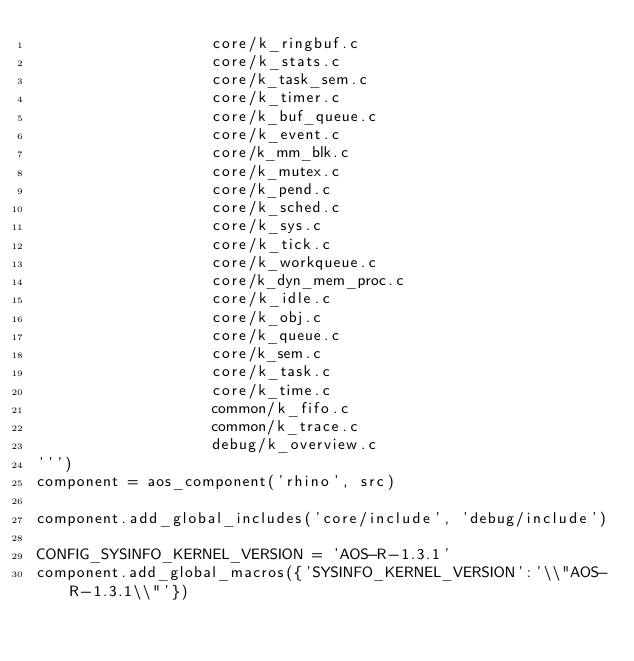<code> <loc_0><loc_0><loc_500><loc_500><_Python_>                   core/k_ringbuf.c      
                   core/k_stats.c        
                   core/k_task_sem.c     
                   core/k_timer.c        
                   core/k_buf_queue.c    
                   core/k_event.c        
                   core/k_mm_blk.c       
                   core/k_mutex.c        
                   core/k_pend.c         
                   core/k_sched.c        
                   core/k_sys.c          
                   core/k_tick.c         
                   core/k_workqueue.c    
                   core/k_dyn_mem_proc.c 
                   core/k_idle.c         
                   core/k_obj.c          
                   core/k_queue.c        
                   core/k_sem.c          
                   core/k_task.c         
                   core/k_time.c         
                   common/k_fifo.c       
                   common/k_trace.c
                   debug/k_overview.c
''')
component = aos_component('rhino', src)

component.add_global_includes('core/include', 'debug/include')

CONFIG_SYSINFO_KERNEL_VERSION = 'AOS-R-1.3.1'
component.add_global_macros({'SYSINFO_KERNEL_VERSION':'\\"AOS-R-1.3.1\\"'})
</code> 